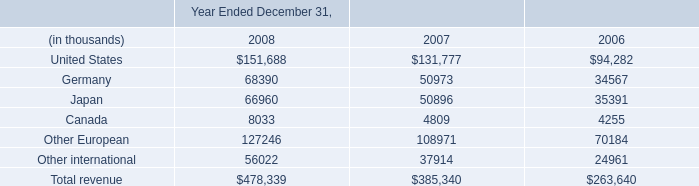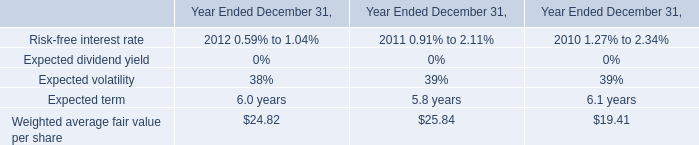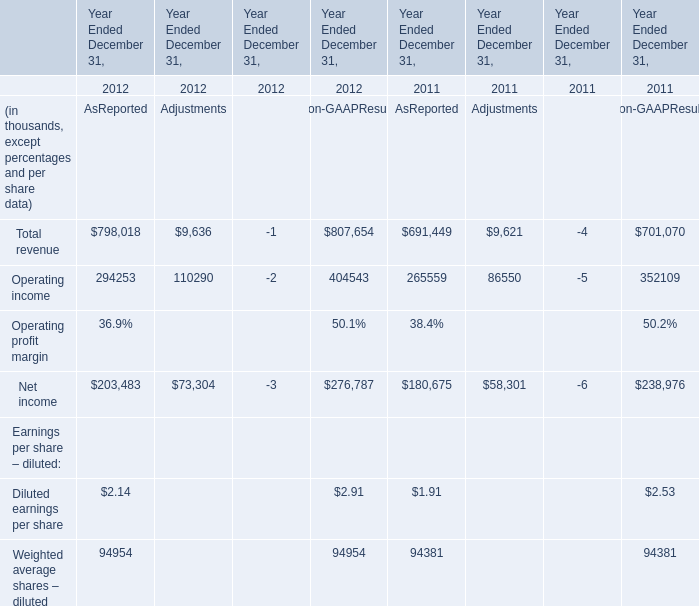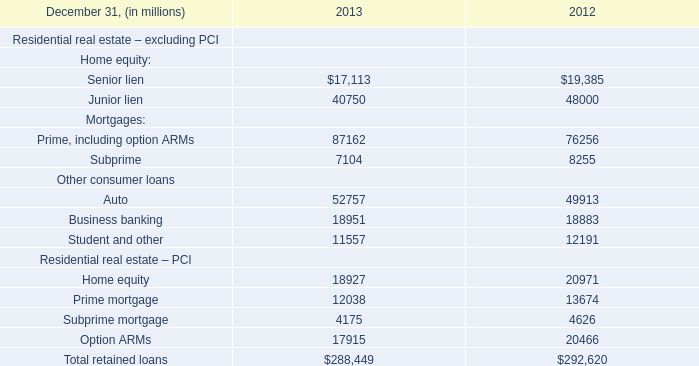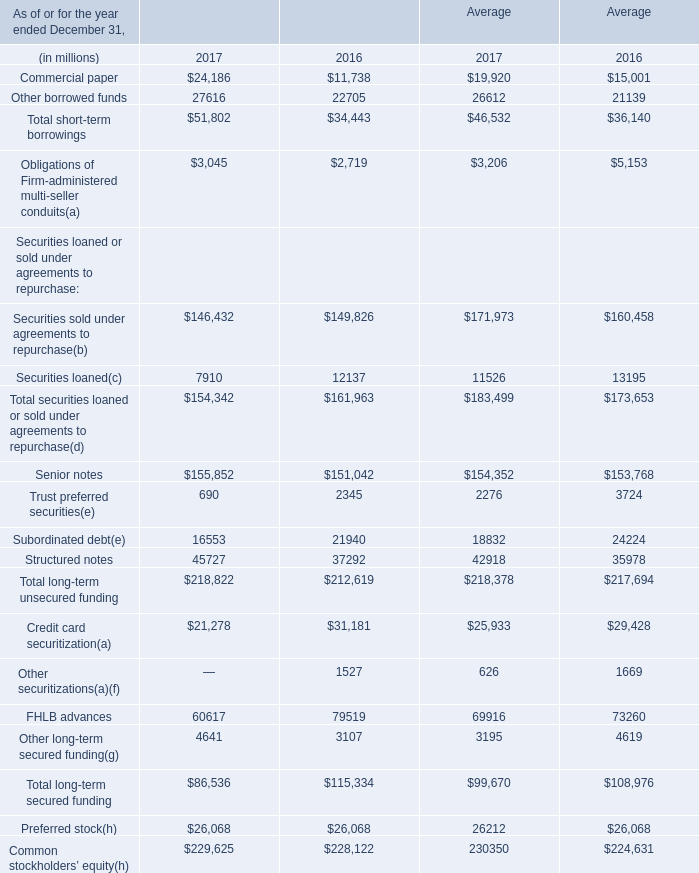What is the average amount of United States of Year Ended December 31, 2008, and Auto Other consumer loans of 2012 ? 
Computations: ((151688.0 + 49913.0) / 2)
Answer: 100800.5. 